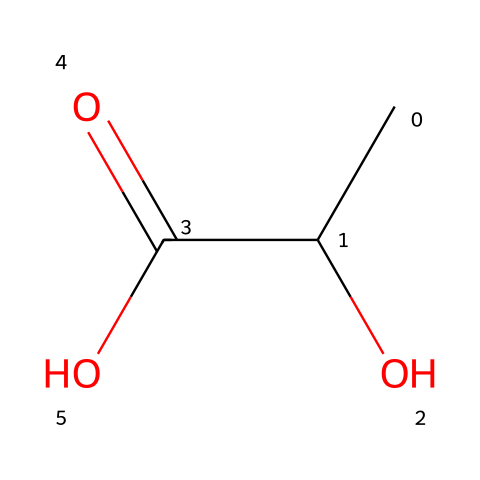What is the name of this chemical? The SMILES representation provided corresponds to lactic acid, which is derived from its structural arrangement featuring a carboxylic acid group and a hydroxyl group on a carbon chain.
Answer: lactic acid How many carbon atoms are in lactic acid? Analyzing the SMILES representation CC(O)C(=O)O, there are three carbon atoms present, which can be identified by the 'C' characters and their connections.
Answer: three What type of functional groups are present in the structure of lactic acid? The chemical structure contains a carboxylic acid group (C(=O)O) and a hydroxyl group (O), both contributing to the acidic and polar properties of lactic acid.
Answer: carboxylic acid and hydroxyl What is the degree of acidity of lactic acid compared to other common acids? Lactic acid is classified as a weak acid, as indicated by its structure which allows it to partially dissociate in solution, distinguishing it from strong acids like hydrochloric acid.
Answer: weak Which characteristic of lactic acid helps in dental health products for dogs? The presence of the carboxylic acid group in lactic acid allows it to help inhibit bacterial growth in oral care products due to its acidic nature, contributing to dental hygiene.
Answer: antibacterial 